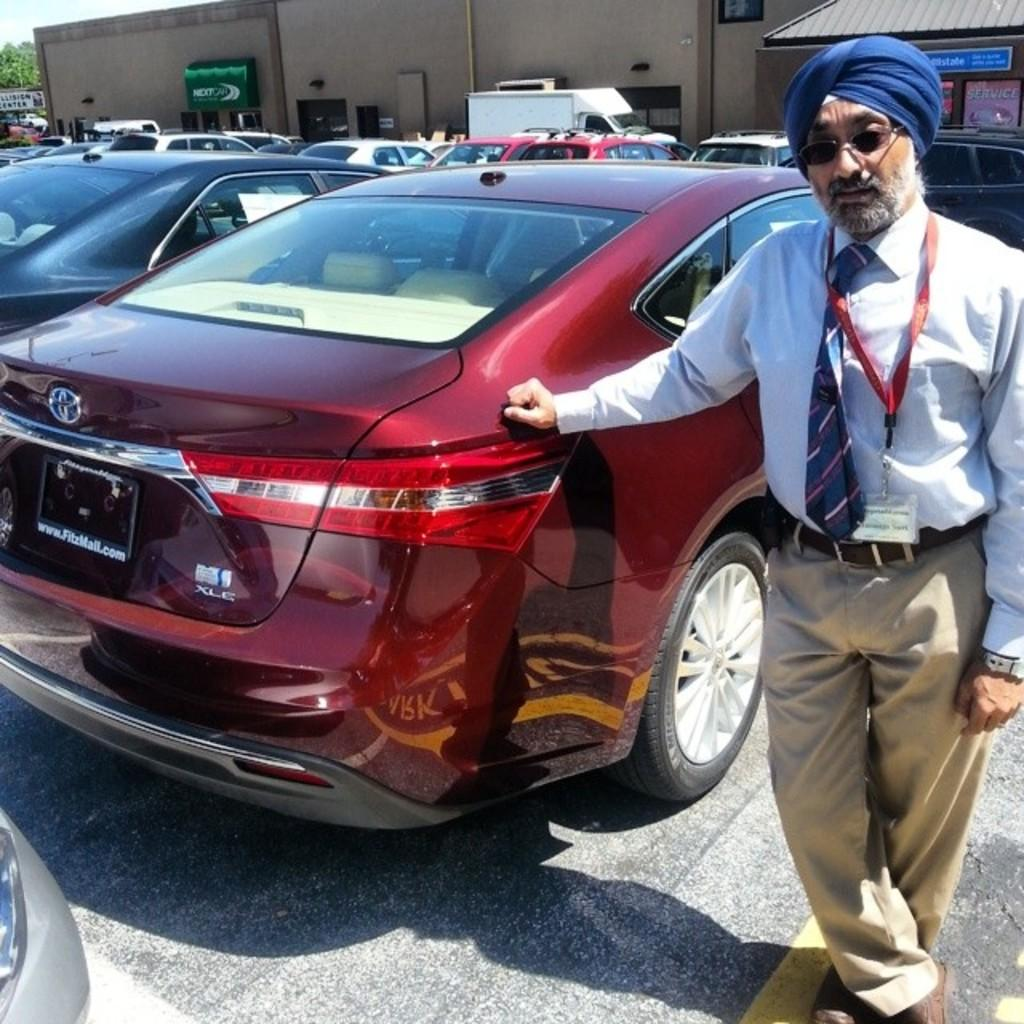What type of vehicles can be seen in the image? There are cars in the image. Can you describe the person in the image? There is a person on the road in the image. What can be seen in the distance behind the cars and person? There are buildings, trees, and the sky visible in the background of the image. What is the weight of the mice running on the cars in the image? There are no mice present in the image, so their weight cannot be determined. 